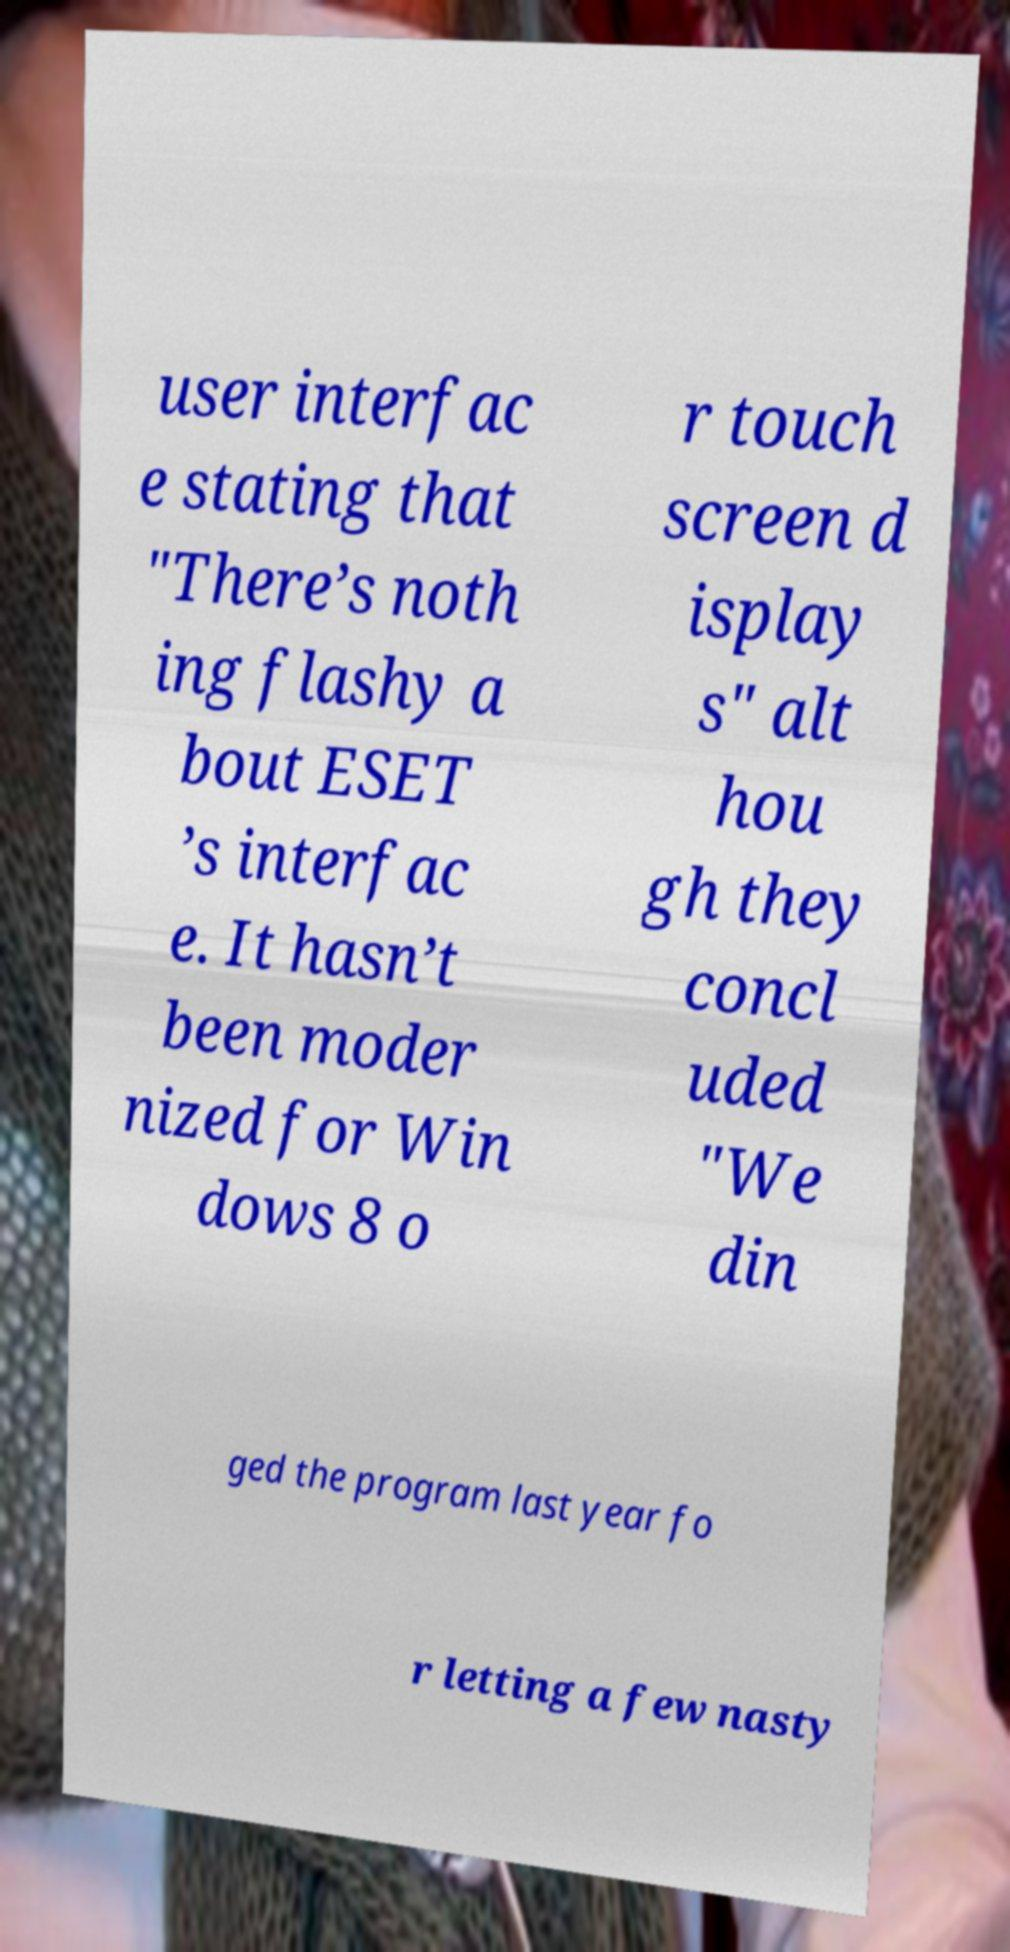Please read and relay the text visible in this image. What does it say? user interfac e stating that "There’s noth ing flashy a bout ESET ’s interfac e. It hasn’t been moder nized for Win dows 8 o r touch screen d isplay s" alt hou gh they concl uded "We din ged the program last year fo r letting a few nasty 